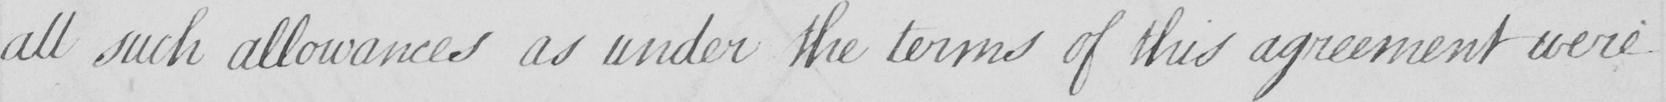Can you read and transcribe this handwriting? all such allowances as under the terms of this agreement were 